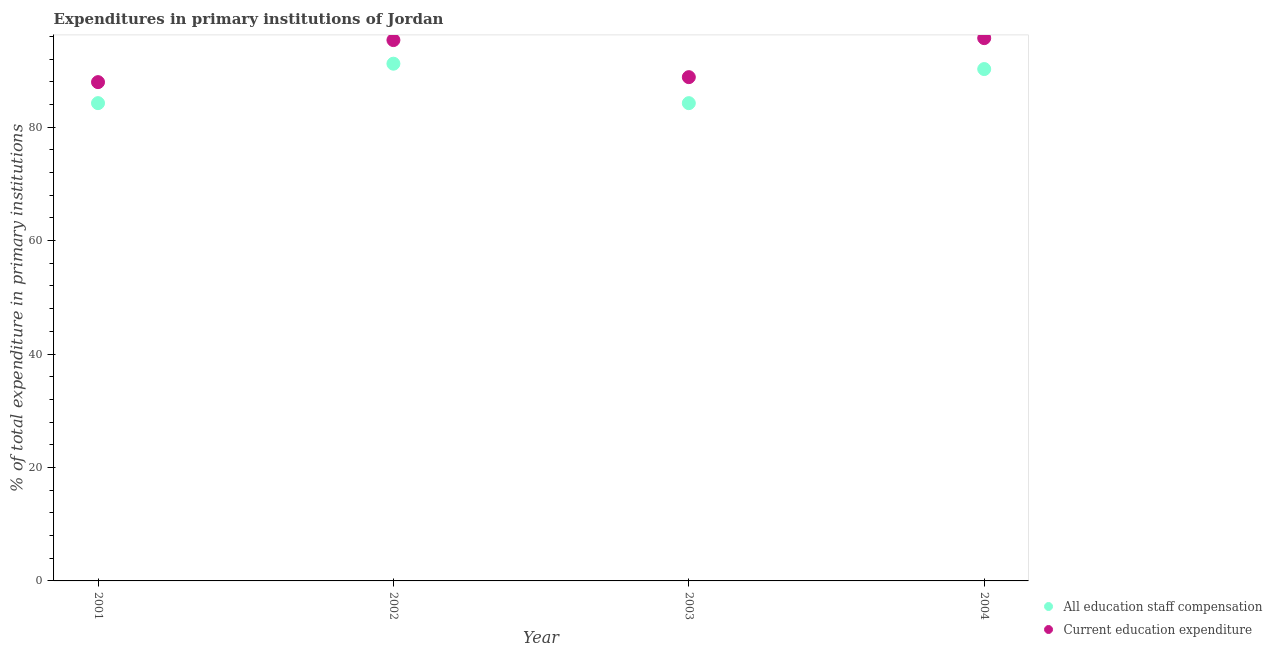What is the expenditure in staff compensation in 2003?
Ensure brevity in your answer.  84.24. Across all years, what is the maximum expenditure in education?
Your response must be concise. 95.7. Across all years, what is the minimum expenditure in staff compensation?
Make the answer very short. 84.24. In which year was the expenditure in staff compensation maximum?
Make the answer very short. 2002. What is the total expenditure in staff compensation in the graph?
Your answer should be very brief. 349.91. What is the difference between the expenditure in education in 2001 and that in 2002?
Ensure brevity in your answer.  -7.41. What is the difference between the expenditure in staff compensation in 2002 and the expenditure in education in 2004?
Your answer should be very brief. -4.51. What is the average expenditure in education per year?
Offer a terse response. 91.95. In the year 2004, what is the difference between the expenditure in staff compensation and expenditure in education?
Keep it short and to the point. -5.45. What is the ratio of the expenditure in education in 2003 to that in 2004?
Your response must be concise. 0.93. Is the expenditure in staff compensation in 2003 less than that in 2004?
Make the answer very short. Yes. Is the difference between the expenditure in education in 2001 and 2003 greater than the difference between the expenditure in staff compensation in 2001 and 2003?
Your response must be concise. No. What is the difference between the highest and the second highest expenditure in staff compensation?
Keep it short and to the point. 0.95. What is the difference between the highest and the lowest expenditure in staff compensation?
Offer a very short reply. 6.96. Is the expenditure in education strictly greater than the expenditure in staff compensation over the years?
Offer a very short reply. Yes. Is the expenditure in staff compensation strictly less than the expenditure in education over the years?
Offer a terse response. Yes. How many dotlines are there?
Your answer should be very brief. 2. How many years are there in the graph?
Provide a short and direct response. 4. What is the difference between two consecutive major ticks on the Y-axis?
Offer a terse response. 20. Does the graph contain any zero values?
Your answer should be compact. No. What is the title of the graph?
Give a very brief answer. Expenditures in primary institutions of Jordan. Does "2012 US$" appear as one of the legend labels in the graph?
Keep it short and to the point. No. What is the label or title of the Y-axis?
Give a very brief answer. % of total expenditure in primary institutions. What is the % of total expenditure in primary institutions in All education staff compensation in 2001?
Make the answer very short. 84.24. What is the % of total expenditure in primary institutions in Current education expenditure in 2001?
Offer a terse response. 87.94. What is the % of total expenditure in primary institutions of All education staff compensation in 2002?
Your response must be concise. 91.19. What is the % of total expenditure in primary institutions in Current education expenditure in 2002?
Provide a succinct answer. 95.35. What is the % of total expenditure in primary institutions of All education staff compensation in 2003?
Your answer should be very brief. 84.24. What is the % of total expenditure in primary institutions of Current education expenditure in 2003?
Provide a succinct answer. 88.82. What is the % of total expenditure in primary institutions in All education staff compensation in 2004?
Offer a terse response. 90.25. What is the % of total expenditure in primary institutions in Current education expenditure in 2004?
Make the answer very short. 95.7. Across all years, what is the maximum % of total expenditure in primary institutions in All education staff compensation?
Your answer should be very brief. 91.19. Across all years, what is the maximum % of total expenditure in primary institutions of Current education expenditure?
Your answer should be very brief. 95.7. Across all years, what is the minimum % of total expenditure in primary institutions of All education staff compensation?
Your response must be concise. 84.24. Across all years, what is the minimum % of total expenditure in primary institutions in Current education expenditure?
Your response must be concise. 87.94. What is the total % of total expenditure in primary institutions of All education staff compensation in the graph?
Make the answer very short. 349.91. What is the total % of total expenditure in primary institutions in Current education expenditure in the graph?
Make the answer very short. 367.82. What is the difference between the % of total expenditure in primary institutions in All education staff compensation in 2001 and that in 2002?
Make the answer very short. -6.96. What is the difference between the % of total expenditure in primary institutions in Current education expenditure in 2001 and that in 2002?
Give a very brief answer. -7.41. What is the difference between the % of total expenditure in primary institutions in All education staff compensation in 2001 and that in 2003?
Your answer should be very brief. 0. What is the difference between the % of total expenditure in primary institutions of Current education expenditure in 2001 and that in 2003?
Ensure brevity in your answer.  -0.88. What is the difference between the % of total expenditure in primary institutions in All education staff compensation in 2001 and that in 2004?
Your response must be concise. -6.01. What is the difference between the % of total expenditure in primary institutions of Current education expenditure in 2001 and that in 2004?
Offer a terse response. -7.76. What is the difference between the % of total expenditure in primary institutions in All education staff compensation in 2002 and that in 2003?
Your response must be concise. 6.96. What is the difference between the % of total expenditure in primary institutions in Current education expenditure in 2002 and that in 2003?
Give a very brief answer. 6.53. What is the difference between the % of total expenditure in primary institutions in All education staff compensation in 2002 and that in 2004?
Your answer should be very brief. 0.95. What is the difference between the % of total expenditure in primary institutions of Current education expenditure in 2002 and that in 2004?
Provide a succinct answer. -0.35. What is the difference between the % of total expenditure in primary institutions in All education staff compensation in 2003 and that in 2004?
Make the answer very short. -6.01. What is the difference between the % of total expenditure in primary institutions in Current education expenditure in 2003 and that in 2004?
Provide a succinct answer. -6.88. What is the difference between the % of total expenditure in primary institutions of All education staff compensation in 2001 and the % of total expenditure in primary institutions of Current education expenditure in 2002?
Provide a short and direct response. -11.12. What is the difference between the % of total expenditure in primary institutions of All education staff compensation in 2001 and the % of total expenditure in primary institutions of Current education expenditure in 2003?
Provide a short and direct response. -4.58. What is the difference between the % of total expenditure in primary institutions of All education staff compensation in 2001 and the % of total expenditure in primary institutions of Current education expenditure in 2004?
Your response must be concise. -11.46. What is the difference between the % of total expenditure in primary institutions of All education staff compensation in 2002 and the % of total expenditure in primary institutions of Current education expenditure in 2003?
Ensure brevity in your answer.  2.37. What is the difference between the % of total expenditure in primary institutions of All education staff compensation in 2002 and the % of total expenditure in primary institutions of Current education expenditure in 2004?
Offer a terse response. -4.51. What is the difference between the % of total expenditure in primary institutions of All education staff compensation in 2003 and the % of total expenditure in primary institutions of Current education expenditure in 2004?
Provide a succinct answer. -11.46. What is the average % of total expenditure in primary institutions of All education staff compensation per year?
Your answer should be compact. 87.48. What is the average % of total expenditure in primary institutions in Current education expenditure per year?
Your answer should be very brief. 91.95. In the year 2001, what is the difference between the % of total expenditure in primary institutions in All education staff compensation and % of total expenditure in primary institutions in Current education expenditure?
Offer a very short reply. -3.7. In the year 2002, what is the difference between the % of total expenditure in primary institutions of All education staff compensation and % of total expenditure in primary institutions of Current education expenditure?
Give a very brief answer. -4.16. In the year 2003, what is the difference between the % of total expenditure in primary institutions in All education staff compensation and % of total expenditure in primary institutions in Current education expenditure?
Your answer should be very brief. -4.58. In the year 2004, what is the difference between the % of total expenditure in primary institutions of All education staff compensation and % of total expenditure in primary institutions of Current education expenditure?
Keep it short and to the point. -5.45. What is the ratio of the % of total expenditure in primary institutions in All education staff compensation in 2001 to that in 2002?
Keep it short and to the point. 0.92. What is the ratio of the % of total expenditure in primary institutions in Current education expenditure in 2001 to that in 2002?
Your answer should be very brief. 0.92. What is the ratio of the % of total expenditure in primary institutions of Current education expenditure in 2001 to that in 2003?
Provide a succinct answer. 0.99. What is the ratio of the % of total expenditure in primary institutions of All education staff compensation in 2001 to that in 2004?
Offer a very short reply. 0.93. What is the ratio of the % of total expenditure in primary institutions of Current education expenditure in 2001 to that in 2004?
Offer a terse response. 0.92. What is the ratio of the % of total expenditure in primary institutions in All education staff compensation in 2002 to that in 2003?
Your answer should be very brief. 1.08. What is the ratio of the % of total expenditure in primary institutions of Current education expenditure in 2002 to that in 2003?
Your response must be concise. 1.07. What is the ratio of the % of total expenditure in primary institutions in All education staff compensation in 2002 to that in 2004?
Provide a short and direct response. 1.01. What is the ratio of the % of total expenditure in primary institutions of Current education expenditure in 2002 to that in 2004?
Ensure brevity in your answer.  1. What is the ratio of the % of total expenditure in primary institutions of All education staff compensation in 2003 to that in 2004?
Make the answer very short. 0.93. What is the ratio of the % of total expenditure in primary institutions in Current education expenditure in 2003 to that in 2004?
Offer a terse response. 0.93. What is the difference between the highest and the second highest % of total expenditure in primary institutions of All education staff compensation?
Your response must be concise. 0.95. What is the difference between the highest and the second highest % of total expenditure in primary institutions in Current education expenditure?
Your answer should be very brief. 0.35. What is the difference between the highest and the lowest % of total expenditure in primary institutions of All education staff compensation?
Offer a terse response. 6.96. What is the difference between the highest and the lowest % of total expenditure in primary institutions of Current education expenditure?
Keep it short and to the point. 7.76. 